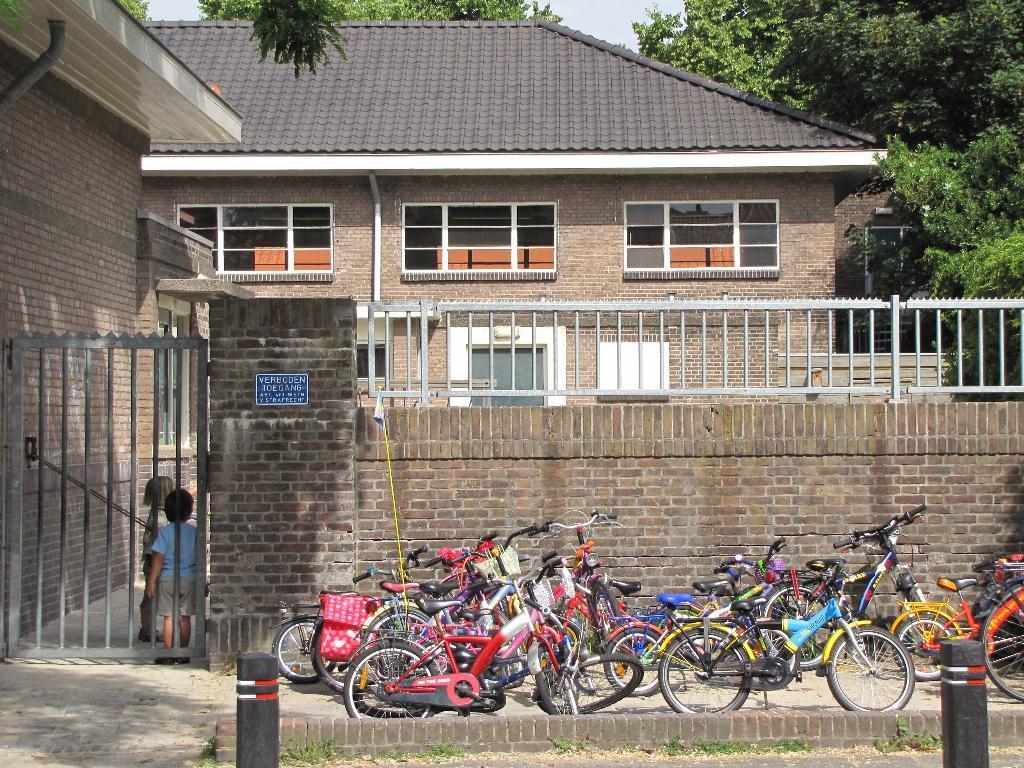How would you summarize this image in a sentence or two? In this image I can see building,windows,gate and trees. In front I can see few bicycles. They are in different color. I can see two children standing. 